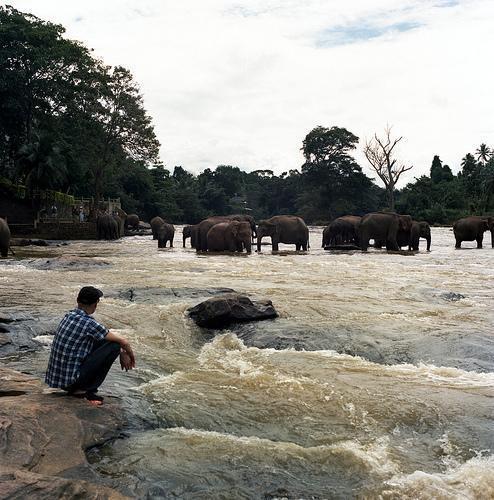How many people are easily seen?
Give a very brief answer. 1. 